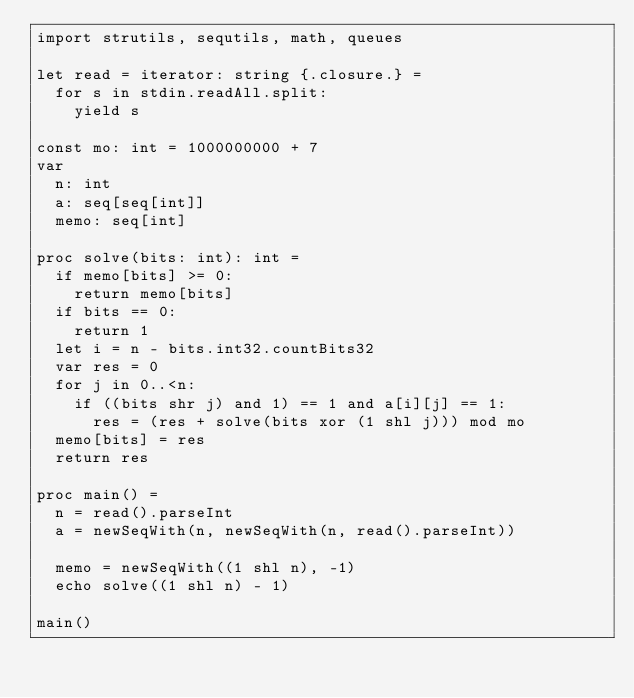<code> <loc_0><loc_0><loc_500><loc_500><_Nim_>import strutils, sequtils, math, queues

let read = iterator: string {.closure.} =
  for s in stdin.readAll.split:
    yield s

const mo: int = 1000000000 + 7
var
  n: int
  a: seq[seq[int]]
  memo: seq[int]

proc solve(bits: int): int =
  if memo[bits] >= 0:
    return memo[bits]
  if bits == 0:
    return 1
  let i = n - bits.int32.countBits32
  var res = 0
  for j in 0..<n:
    if ((bits shr j) and 1) == 1 and a[i][j] == 1:
      res = (res + solve(bits xor (1 shl j))) mod mo
  memo[bits] = res
  return res

proc main() =
  n = read().parseInt
  a = newSeqWith(n, newSeqWith(n, read().parseInt))

  memo = newSeqWith((1 shl n), -1)
  echo solve((1 shl n) - 1)

main()
</code> 